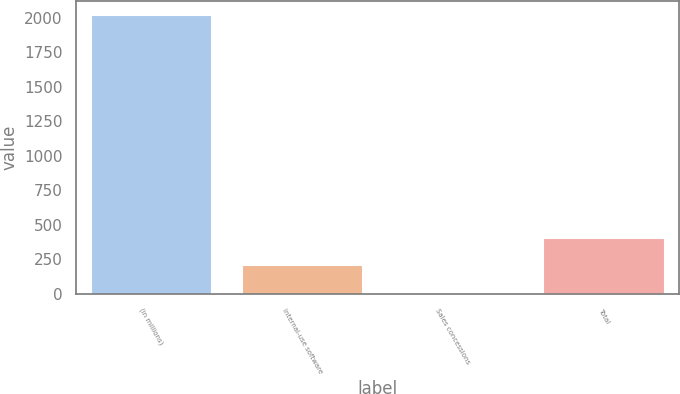Convert chart to OTSL. <chart><loc_0><loc_0><loc_500><loc_500><bar_chart><fcel>(in millions)<fcel>Internal-use software<fcel>Sales concessions<fcel>Total<nl><fcel>2018<fcel>207.2<fcel>6<fcel>408.4<nl></chart> 